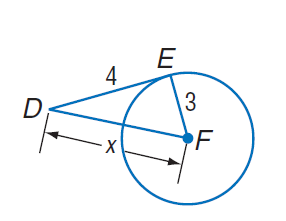Question: E D is tangent to \odot F at point E. Find x.
Choices:
A. 3
B. 4
C. 5
D. 6
Answer with the letter. Answer: C 